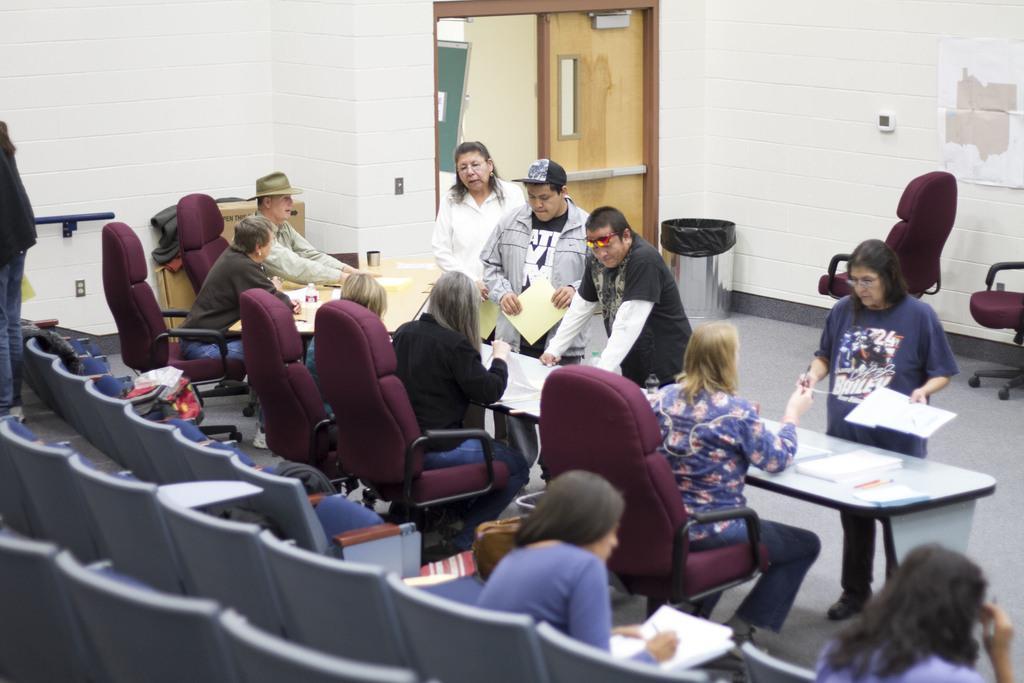Describe this image in one or two sentences. In this image it seems like a hall in which there are people who are sitting in the chairs near the table. There are few other people who are standing near the table and talking with the people who are sitting. At the background there is wall,door and dustbin. 